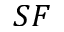Convert formula to latex. <formula><loc_0><loc_0><loc_500><loc_500>S F</formula> 